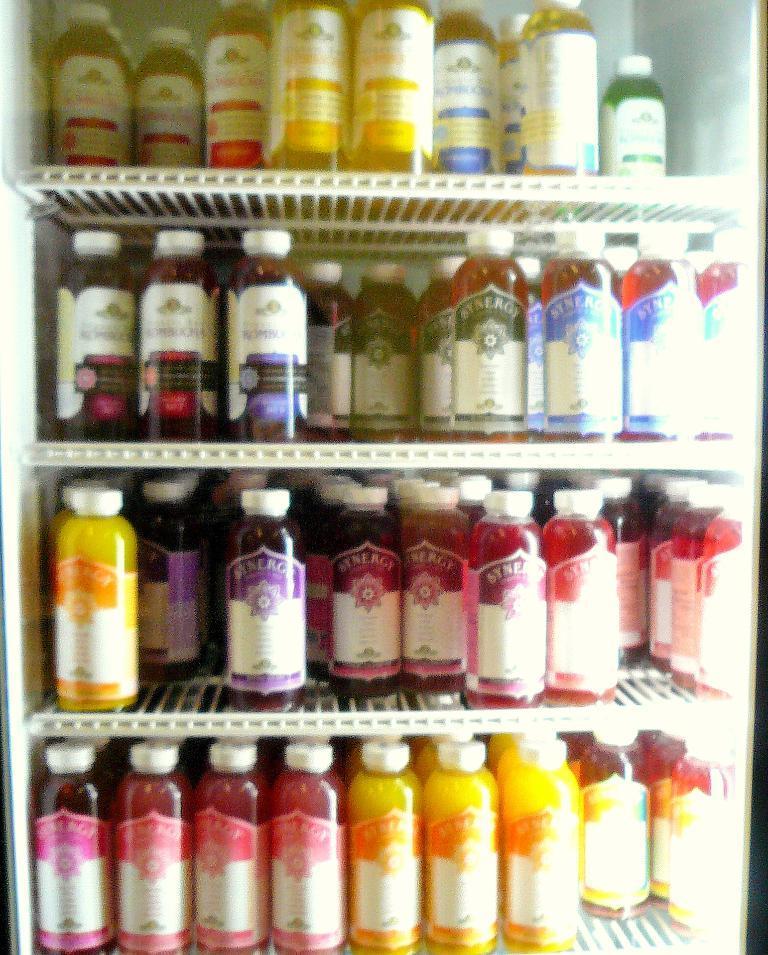Please provide a concise description of this image. In this picture we can see a racks with bottles in it of different colors of liquid such as yellow, red. 